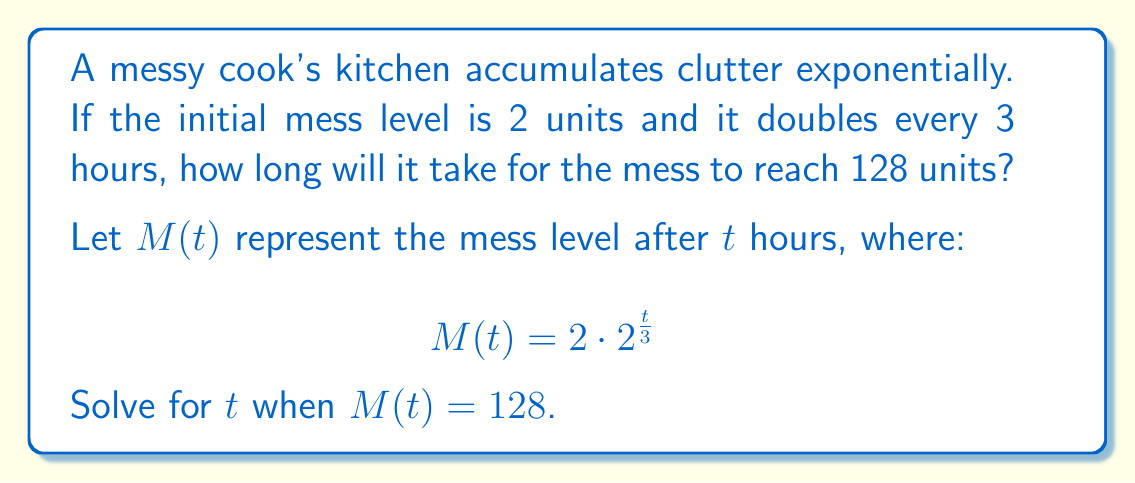Teach me how to tackle this problem. Let's solve this step-by-step:

1) We start with the given equation:
   $$M(t) = 2 \cdot 2^{\frac{t}{3}}$$

2) We want to find $t$ when $M(t) = 128$, so we set up the equation:
   $$128 = 2 \cdot 2^{\frac{t}{3}}$$

3) Divide both sides by 2:
   $$64 = 2^{\frac{t}{3}}$$

4) Take the logarithm (base 2) of both sides:
   $$\log_2(64) = \log_2(2^{\frac{t}{3}})$$

5) Using the logarithm property $\log_a(a^x) = x$, we get:
   $$\log_2(64) = \frac{t}{3}$$

6) We know that $\log_2(64) = 6$ because $2^6 = 64$, so:
   $$6 = \frac{t}{3}$$

7) Multiply both sides by 3:
   $$18 = t$$

Therefore, it will take 18 hours for the mess to reach 128 units.
Answer: 18 hours 